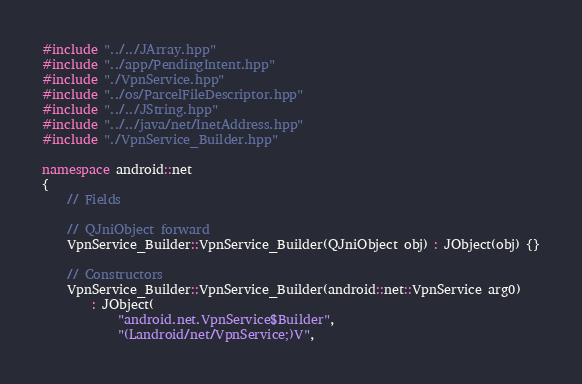<code> <loc_0><loc_0><loc_500><loc_500><_C++_>#include "../../JArray.hpp"
#include "../app/PendingIntent.hpp"
#include "./VpnService.hpp"
#include "../os/ParcelFileDescriptor.hpp"
#include "../../JString.hpp"
#include "../../java/net/InetAddress.hpp"
#include "./VpnService_Builder.hpp"

namespace android::net
{
	// Fields
	
	// QJniObject forward
	VpnService_Builder::VpnService_Builder(QJniObject obj) : JObject(obj) {}
	
	// Constructors
	VpnService_Builder::VpnService_Builder(android::net::VpnService arg0)
		: JObject(
			"android.net.VpnService$Builder",
			"(Landroid/net/VpnService;)V",</code> 